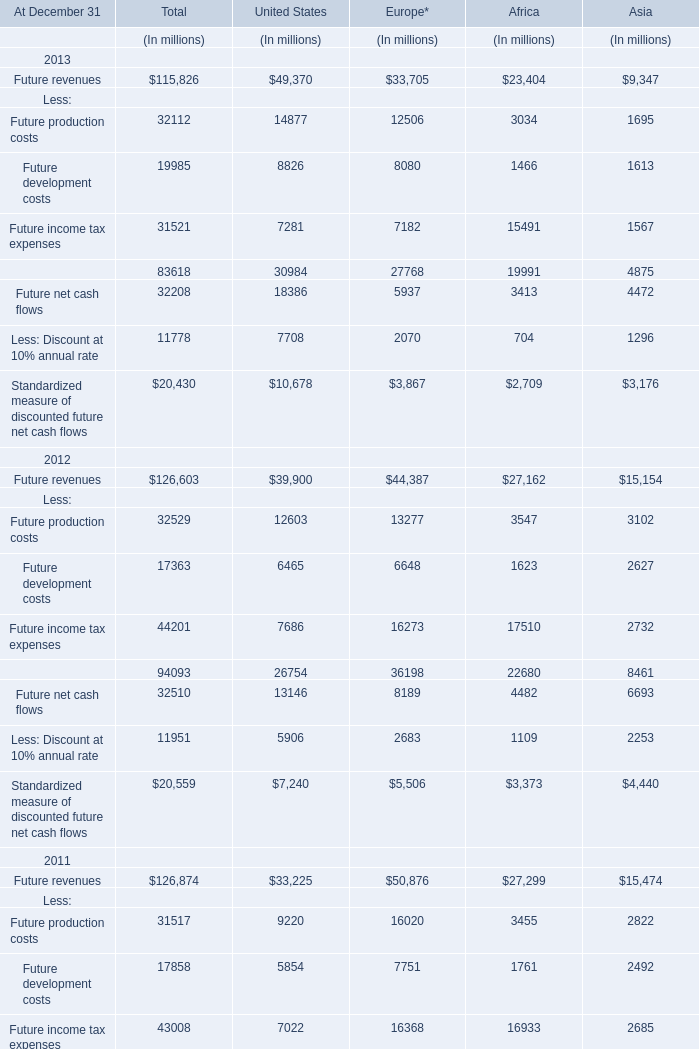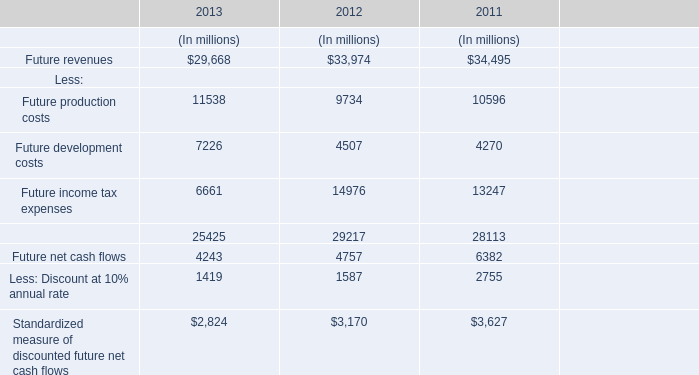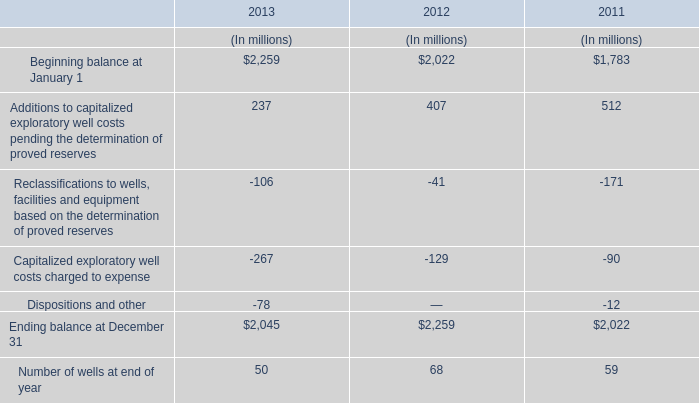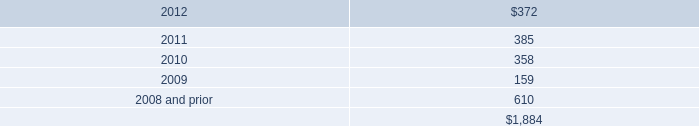What's the average of Future revenues in 2013? (in million) 
Computations: (((((115826 + 49370) + 33705) + 23404) + 9347) / 5)
Answer: 46330.4. 